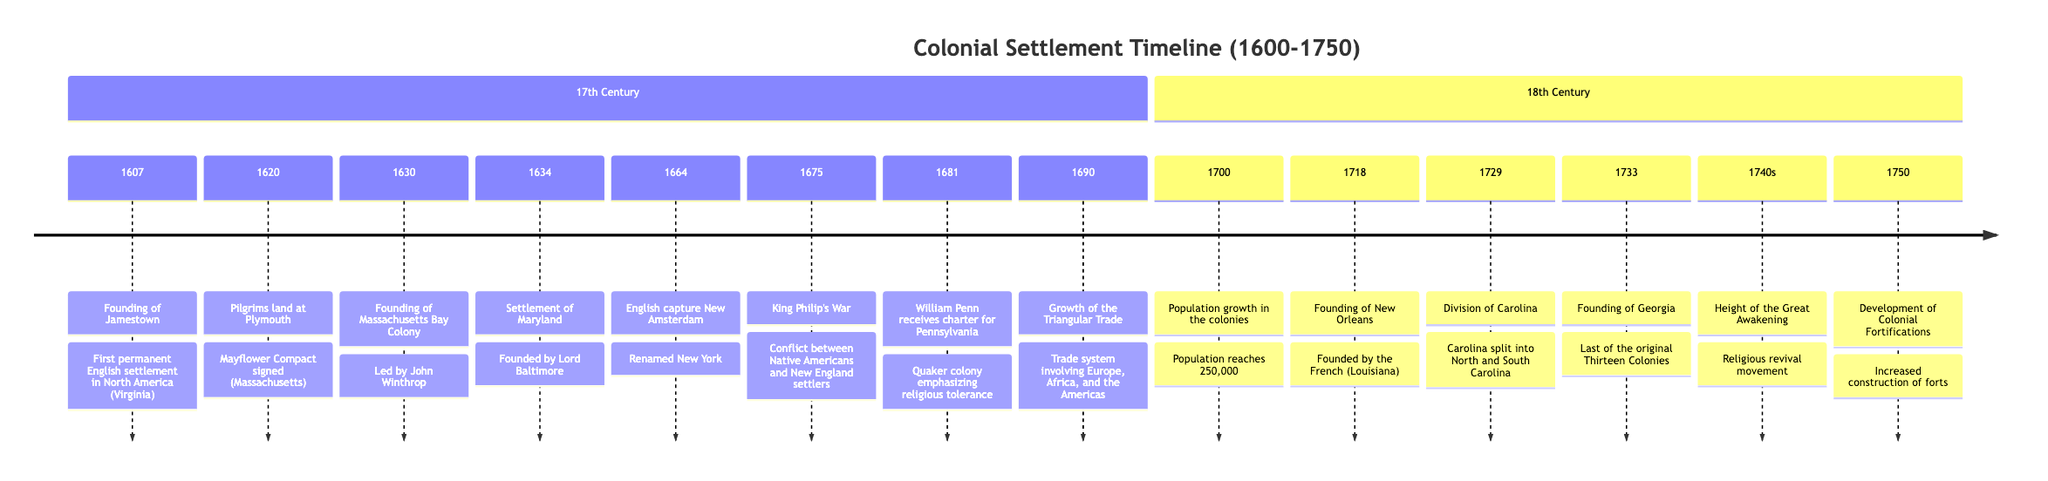What year was Jamestown founded? The timeline indicates that Jamestown was founded in 1607. This information is presented at the top of the 17th Century section.
Answer: 1607 What event marked the signing of the Mayflower Compact? According to the timeline, the landing of the Pilgrims at Plymouth in 1620 is the event associated with the signing of the Mayflower Compact. This is noted directly under the event in the timeline.
Answer: Pilgrims land at Plymouth Which colony was founded by William Penn? The timeline shows that William Penn received the charter for Pennsylvania in 1681, indicating that he founded Pennsylvania. This is explicitly stated under that date in the timeline.
Answer: Pennsylvania What was the population of the colonies around the year 1700? The timeline reveals that in 1700, the population of the colonies was at 250,000, as noted in the population growth event. It is clearly stated under that year.
Answer: 250,000 What significant trade system emerged around 1690? The timeline mentions the growth of the Triangular Trade as significant, noting its connection to Europe, Africa, and the Americas, which reflects evolving trade patterns. This is described in the event for 1690.
Answer: Triangular Trade What was a cause of King Philip's War in 1675? The timeline describes King Philip's War as a conflict between Native Americans and New England settlers, thereby indicating the cause was this conflict. The details are provided directly under the event in the timeline for 1675.
Answer: Conflict between Native Americans and New England settlers In which year was Georgia founded? The timeline specifies that Georgia was founded in 1733, which is clearly marked in the 18th Century section of the timeline.
Answer: 1733 What was a key characteristic of the colony of Maryland founded in 1634? The timeline states that Maryland was founded as a haven for English Catholics, which is a significant characteristic highlighted in the event details for 1634.
Answer: Haven for English Catholics What does the development of colonial fortifications in 1750 indicate? The timeline indicates an increase in the construction of forts in 1750, which reflects the need for defense against European rivals and Native American groups. This explanation is found under the event for that year.
Answer: Defense against European rivals and Native American groups 